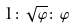Convert formula to latex. <formula><loc_0><loc_0><loc_500><loc_500>1 \colon \sqrt { \varphi } \colon \varphi</formula> 